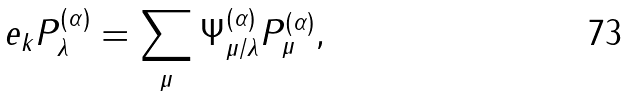Convert formula to latex. <formula><loc_0><loc_0><loc_500><loc_500>e _ { k } P _ { \lambda } ^ { ( \alpha ) } = \sum _ { \mu } { \Psi } _ { \mu / \lambda } ^ { ( \alpha ) } P _ { \mu } ^ { ( \alpha ) } ,</formula> 